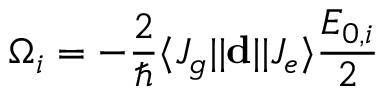Convert formula to latex. <formula><loc_0><loc_0><loc_500><loc_500>\Omega _ { i } = - \frac { 2 } { } \langle J _ { g } | | d | | J _ { e } \rangle \frac { E _ { 0 , i } } { 2 }</formula> 